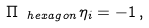Convert formula to latex. <formula><loc_0><loc_0><loc_500><loc_500>\Pi _ { \ h e x a g o n } \eta _ { i } = - 1 \, ,</formula> 